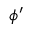<formula> <loc_0><loc_0><loc_500><loc_500>\phi ^ { \prime }</formula> 